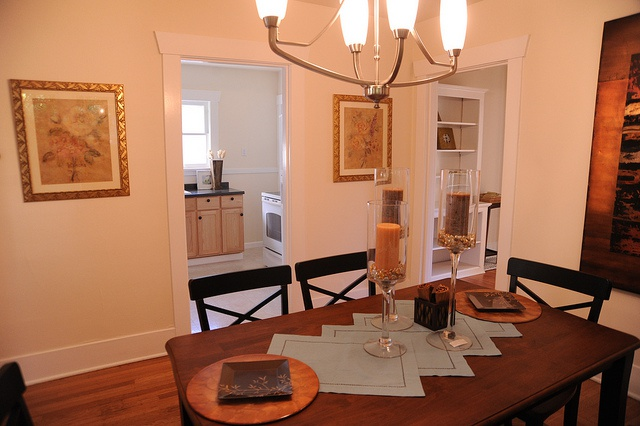Describe the objects in this image and their specific colors. I can see dining table in brown, maroon, and black tones, chair in brown, black, tan, and salmon tones, wine glass in brown, gray, maroon, and salmon tones, chair in brown, black, darkgray, and gray tones, and wine glass in brown, gray, maroon, and tan tones in this image. 